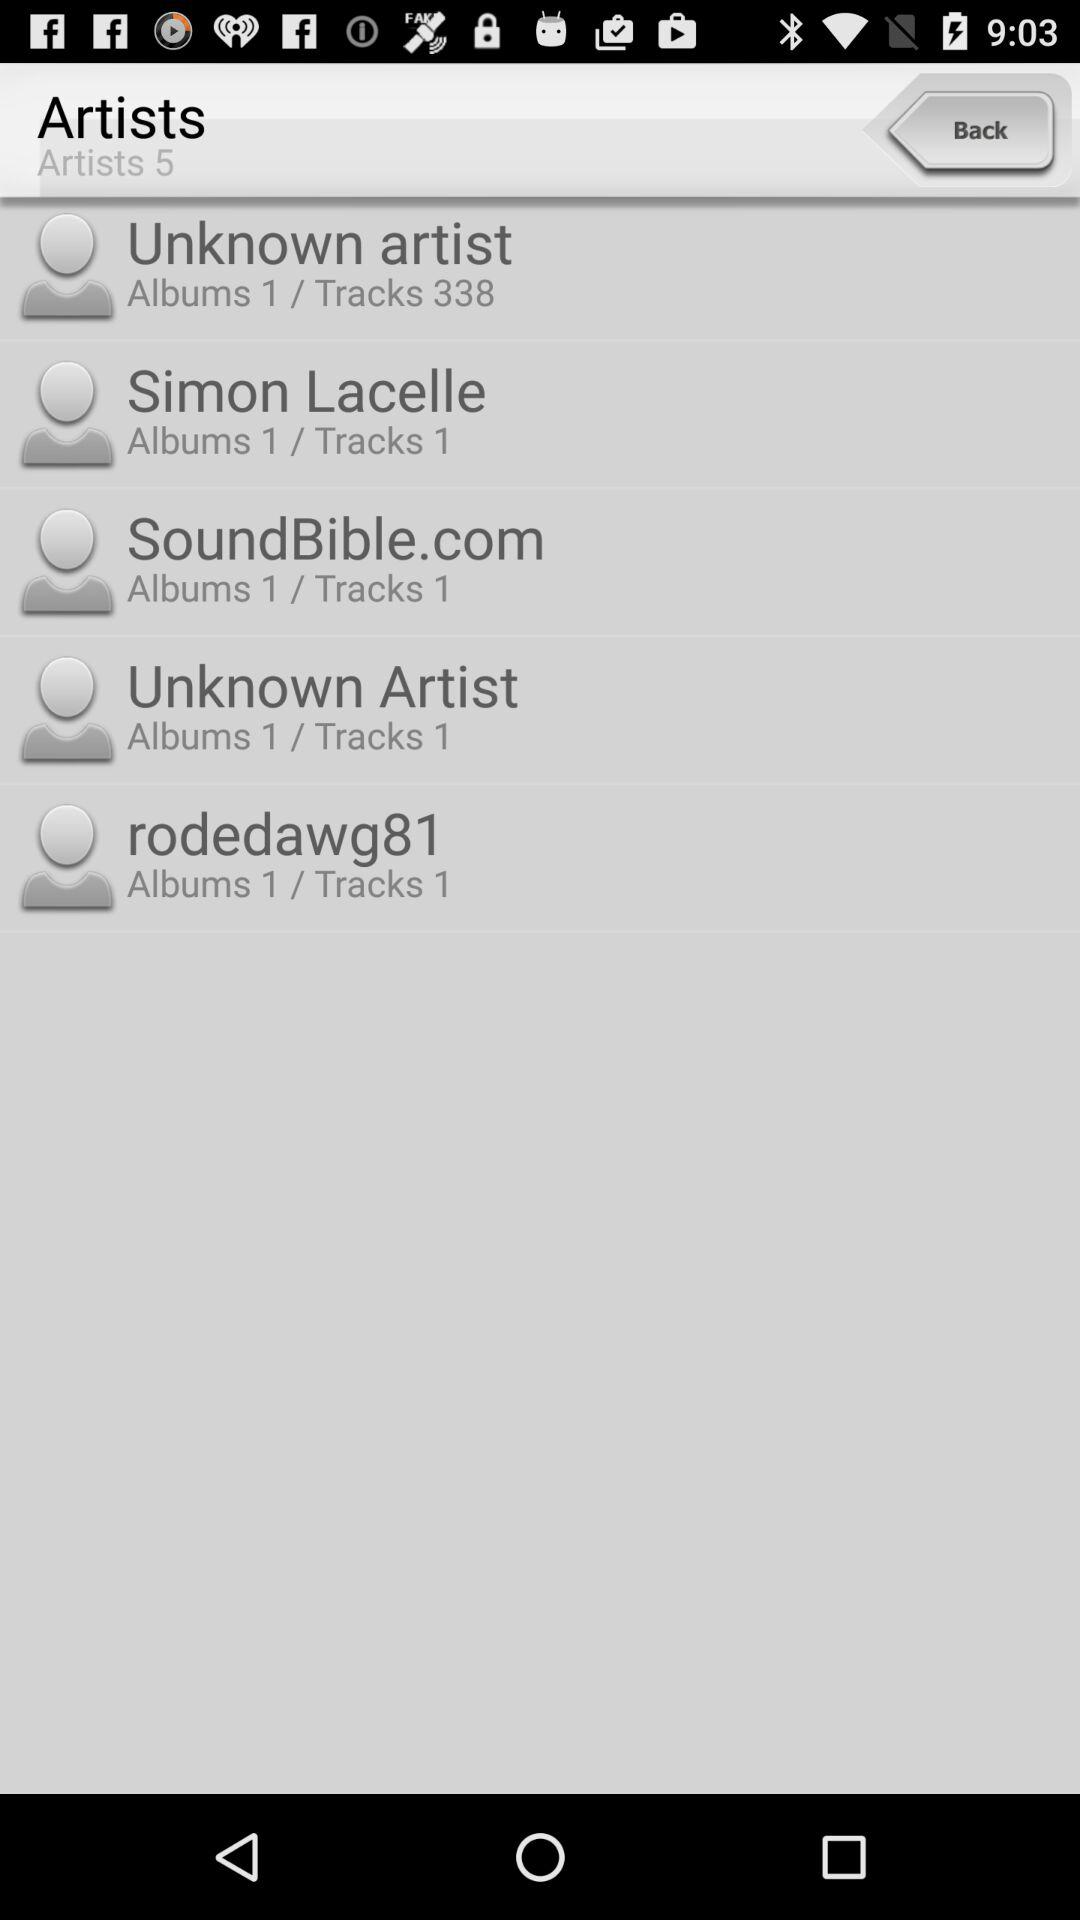How many tracks does Simon Lacelle have? Simon Lacelle has 1 track. 